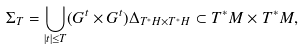<formula> <loc_0><loc_0><loc_500><loc_500>\Sigma _ { T } = \bigcup _ { | t | \leq T } ( G ^ { t } \times G ^ { t } ) \Delta _ { T ^ { * } H \times T ^ { * } H } \subset T ^ { * } M \times T ^ { * } M ,</formula> 